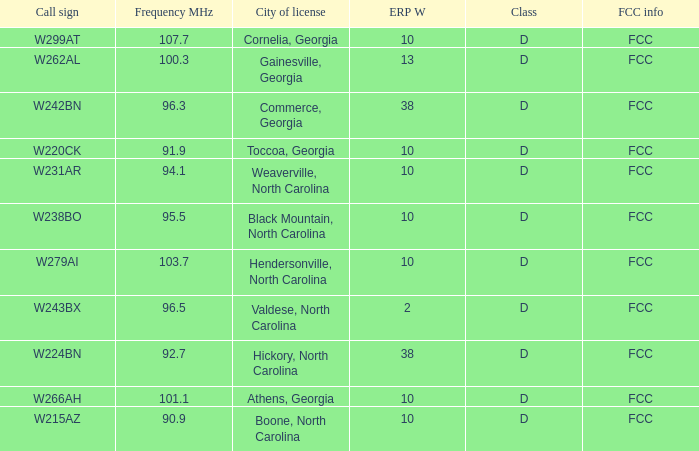What is the Frequency MHz for the station with a call sign of w224bn? 92.7. 